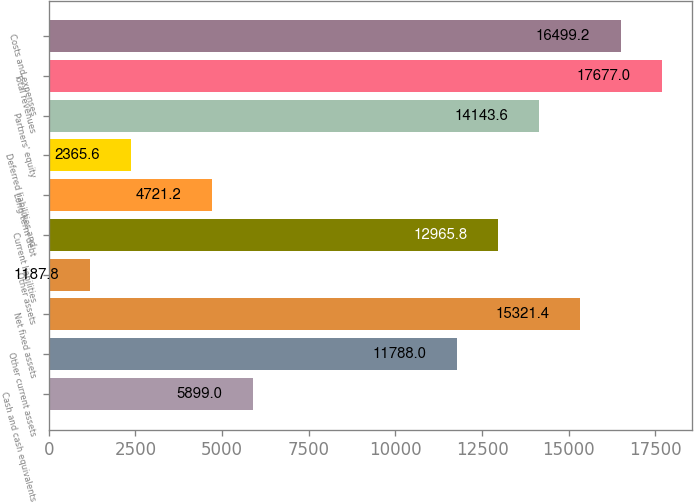Convert chart. <chart><loc_0><loc_0><loc_500><loc_500><bar_chart><fcel>Cash and cash equivalents<fcel>Other current assets<fcel>Net fixed assets<fcel>Other assets<fcel>Current liabilities<fcel>Long-term debt<fcel>Deferred liabilities and<fcel>Partners' equity<fcel>Total revenues<fcel>Costs and expenses<nl><fcel>5899<fcel>11788<fcel>15321.4<fcel>1187.8<fcel>12965.8<fcel>4721.2<fcel>2365.6<fcel>14143.6<fcel>17677<fcel>16499.2<nl></chart> 